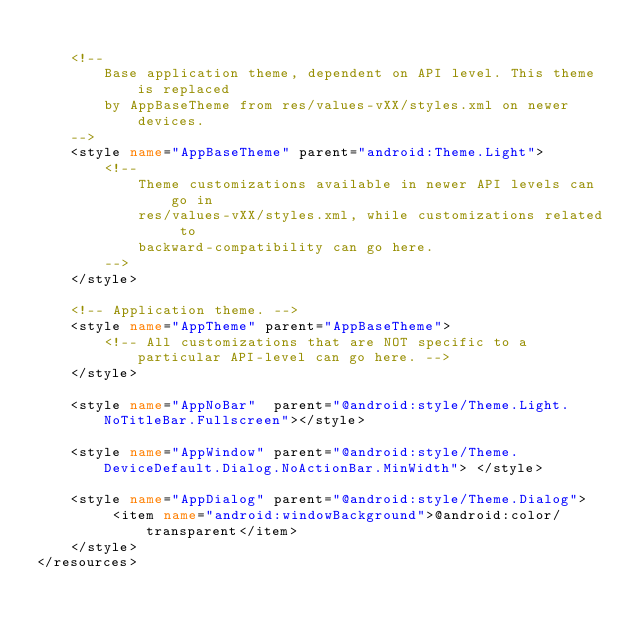<code> <loc_0><loc_0><loc_500><loc_500><_XML_>
    <!--
        Base application theme, dependent on API level. This theme is replaced
        by AppBaseTheme from res/values-vXX/styles.xml on newer devices.
    -->
    <style name="AppBaseTheme" parent="android:Theme.Light">
        <!--
            Theme customizations available in newer API levels can go in
            res/values-vXX/styles.xml, while customizations related to
            backward-compatibility can go here.
        -->
    </style>

    <!-- Application theme. -->
    <style name="AppTheme" parent="AppBaseTheme">
        <!-- All customizations that are NOT specific to a particular API-level can go here. -->
    </style>
    
    <style name="AppNoBar"  parent="@android:style/Theme.Light.NoTitleBar.Fullscreen"></style>
    
    <style name="AppWindow" parent="@android:style/Theme.DeviceDefault.Dialog.NoActionBar.MinWidth"> </style>
    
    <style name="AppDialog" parent="@android:style/Theme.Dialog">
         <item name="android:windowBackground">@android:color/transparent</item>
    </style>
</resources>
</code> 